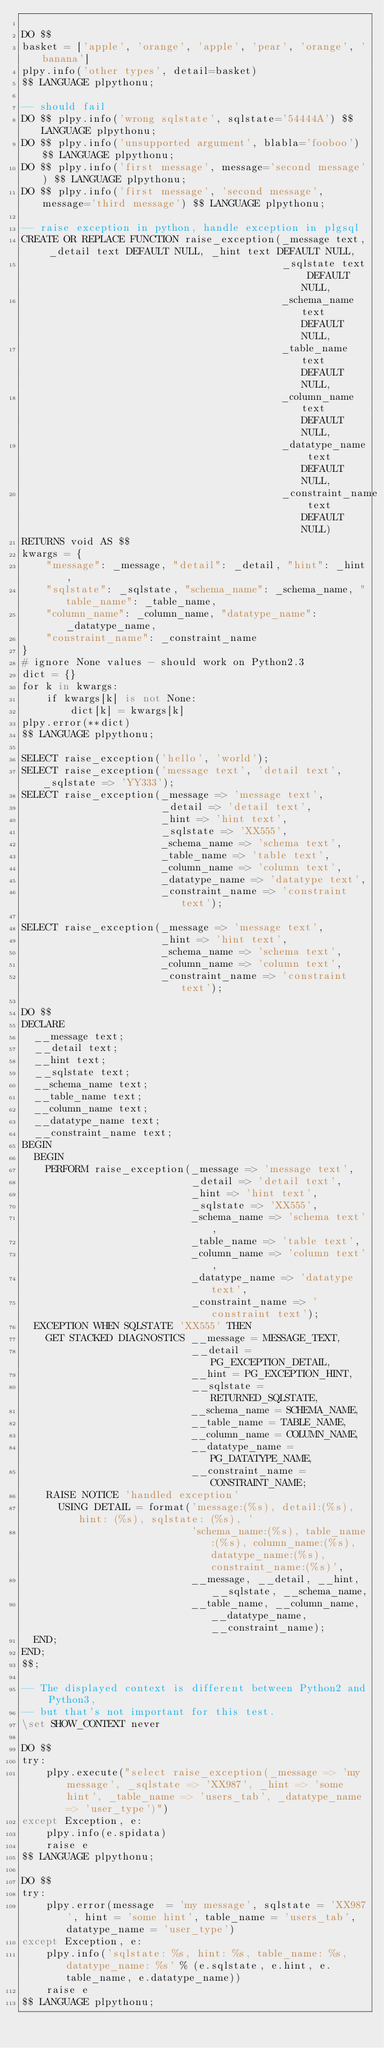Convert code to text. <code><loc_0><loc_0><loc_500><loc_500><_SQL_>
DO $$
basket = ['apple', 'orange', 'apple', 'pear', 'orange', 'banana']
plpy.info('other types', detail=basket)
$$ LANGUAGE plpythonu;

-- should fail
DO $$ plpy.info('wrong sqlstate', sqlstate='54444A') $$ LANGUAGE plpythonu;
DO $$ plpy.info('unsupported argument', blabla='fooboo') $$ LANGUAGE plpythonu;
DO $$ plpy.info('first message', message='second message') $$ LANGUAGE plpythonu;
DO $$ plpy.info('first message', 'second message', message='third message') $$ LANGUAGE plpythonu;

-- raise exception in python, handle exception in plgsql
CREATE OR REPLACE FUNCTION raise_exception(_message text, _detail text DEFAULT NULL, _hint text DEFAULT NULL,
                                           _sqlstate text DEFAULT NULL,
                                           _schema_name text DEFAULT NULL,
                                           _table_name text DEFAULT NULL,
                                           _column_name text DEFAULT NULL,
                                           _datatype_name text DEFAULT NULL,
                                           _constraint_name text DEFAULT NULL)
RETURNS void AS $$
kwargs = {
    "message": _message, "detail": _detail, "hint": _hint,
    "sqlstate": _sqlstate, "schema_name": _schema_name, "table_name": _table_name,
    "column_name": _column_name, "datatype_name": _datatype_name,
    "constraint_name": _constraint_name
}
# ignore None values - should work on Python2.3
dict = {}
for k in kwargs:
    if kwargs[k] is not None:
        dict[k] = kwargs[k]
plpy.error(**dict)
$$ LANGUAGE plpythonu;

SELECT raise_exception('hello', 'world');
SELECT raise_exception('message text', 'detail text', _sqlstate => 'YY333');
SELECT raise_exception(_message => 'message text',
                       _detail => 'detail text',
                       _hint => 'hint text',
                       _sqlstate => 'XX555',
                       _schema_name => 'schema text',
                       _table_name => 'table text',
                       _column_name => 'column text',
                       _datatype_name => 'datatype text',
                       _constraint_name => 'constraint text');

SELECT raise_exception(_message => 'message text',
                       _hint => 'hint text',
                       _schema_name => 'schema text',
                       _column_name => 'column text',
                       _constraint_name => 'constraint text');

DO $$
DECLARE
  __message text;
  __detail text;
  __hint text;
  __sqlstate text;
  __schema_name text;
  __table_name text;
  __column_name text;
  __datatype_name text;
  __constraint_name text;
BEGIN
  BEGIN
    PERFORM raise_exception(_message => 'message text',
                            _detail => 'detail text',
                            _hint => 'hint text',
                            _sqlstate => 'XX555',
                            _schema_name => 'schema text',
                            _table_name => 'table text',
                            _column_name => 'column text',
                            _datatype_name => 'datatype text',
                            _constraint_name => 'constraint text');
  EXCEPTION WHEN SQLSTATE 'XX555' THEN
    GET STACKED DIAGNOSTICS __message = MESSAGE_TEXT,
                            __detail = PG_EXCEPTION_DETAIL,
                            __hint = PG_EXCEPTION_HINT,
                            __sqlstate = RETURNED_SQLSTATE,
                            __schema_name = SCHEMA_NAME,
                            __table_name = TABLE_NAME,
                            __column_name = COLUMN_NAME,
                            __datatype_name = PG_DATATYPE_NAME,
                            __constraint_name = CONSTRAINT_NAME;
    RAISE NOTICE 'handled exception'
      USING DETAIL = format('message:(%s), detail:(%s), hint: (%s), sqlstate: (%s), '
                            'schema_name:(%s), table_name:(%s), column_name:(%s), datatype_name:(%s), constraint_name:(%s)',
                            __message, __detail, __hint, __sqlstate, __schema_name,
                            __table_name, __column_name, __datatype_name, __constraint_name);
  END;
END;
$$;

-- The displayed context is different between Python2 and Python3,
-- but that's not important for this test.
\set SHOW_CONTEXT never

DO $$
try:
    plpy.execute("select raise_exception(_message => 'my message', _sqlstate => 'XX987', _hint => 'some hint', _table_name => 'users_tab', _datatype_name => 'user_type')")
except Exception, e:
    plpy.info(e.spidata)
    raise e
$$ LANGUAGE plpythonu;

DO $$
try:
    plpy.error(message  = 'my message', sqlstate = 'XX987', hint = 'some hint', table_name = 'users_tab', datatype_name = 'user_type')
except Exception, e:
    plpy.info('sqlstate: %s, hint: %s, table_name: %s, datatype_name: %s' % (e.sqlstate, e.hint, e.table_name, e.datatype_name))
    raise e
$$ LANGUAGE plpythonu;
</code> 